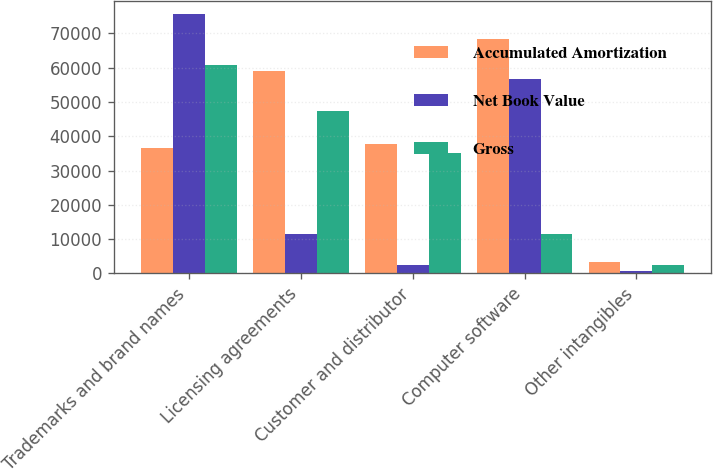Convert chart. <chart><loc_0><loc_0><loc_500><loc_500><stacked_bar_chart><ecel><fcel>Trademarks and brand names<fcel>Licensing agreements<fcel>Customer and distributor<fcel>Computer software<fcel>Other intangibles<nl><fcel>Accumulated Amortization<fcel>36439<fcel>58901<fcel>37654<fcel>68254<fcel>3281<nl><fcel>Net Book Value<fcel>75559<fcel>11501<fcel>2430<fcel>56658<fcel>770<nl><fcel>Gross<fcel>60820<fcel>47400<fcel>35224<fcel>11596<fcel>2511<nl></chart> 